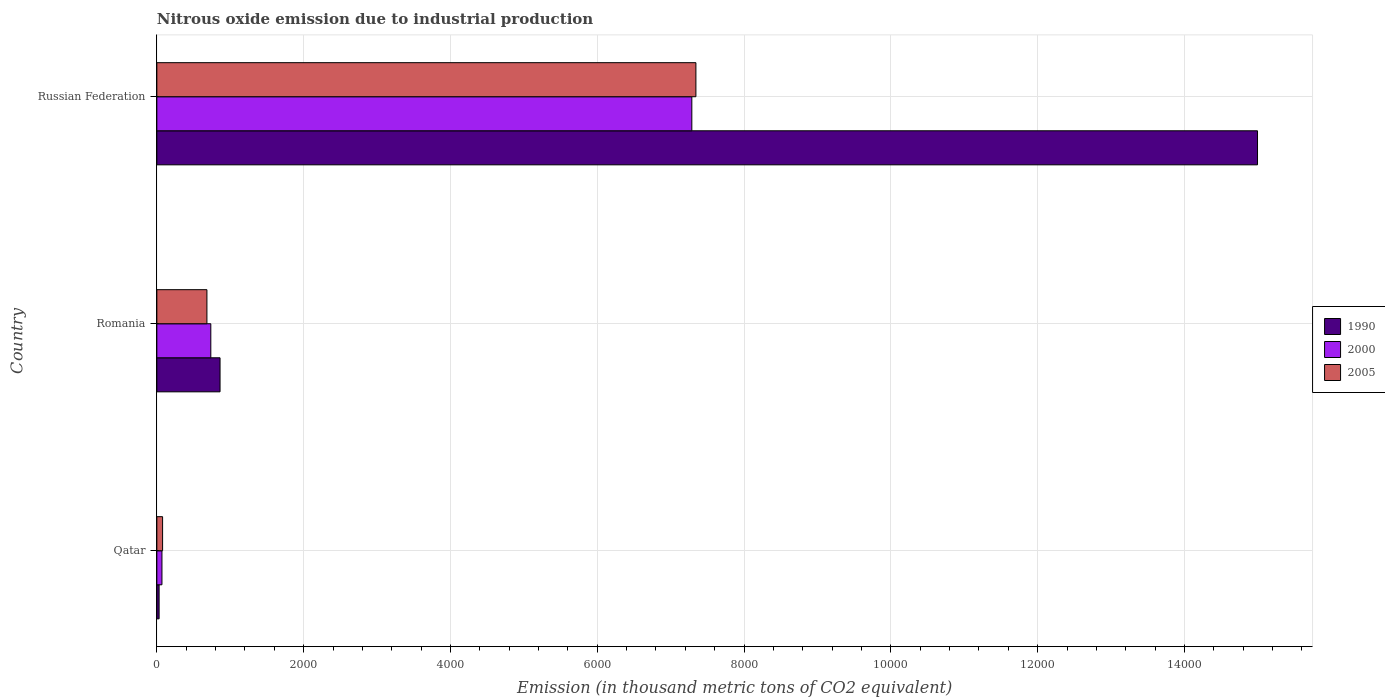Are the number of bars on each tick of the Y-axis equal?
Keep it short and to the point. Yes. What is the label of the 2nd group of bars from the top?
Make the answer very short. Romania. What is the amount of nitrous oxide emitted in 2005 in Qatar?
Make the answer very short. 78.2. Across all countries, what is the maximum amount of nitrous oxide emitted in 2005?
Your response must be concise. 7344.1. Across all countries, what is the minimum amount of nitrous oxide emitted in 2005?
Your answer should be compact. 78.2. In which country was the amount of nitrous oxide emitted in 2005 maximum?
Provide a short and direct response. Russian Federation. In which country was the amount of nitrous oxide emitted in 2005 minimum?
Provide a short and direct response. Qatar. What is the total amount of nitrous oxide emitted in 1990 in the graph?
Provide a short and direct response. 1.59e+04. What is the difference between the amount of nitrous oxide emitted in 2005 in Qatar and that in Russian Federation?
Make the answer very short. -7265.9. What is the difference between the amount of nitrous oxide emitted in 2005 in Russian Federation and the amount of nitrous oxide emitted in 2000 in Romania?
Offer a terse response. 6608.8. What is the average amount of nitrous oxide emitted in 2005 per country?
Offer a very short reply. 2701.53. What is the difference between the amount of nitrous oxide emitted in 1990 and amount of nitrous oxide emitted in 2005 in Romania?
Provide a succinct answer. 178.8. In how many countries, is the amount of nitrous oxide emitted in 2000 greater than 3200 thousand metric tons?
Your response must be concise. 1. What is the ratio of the amount of nitrous oxide emitted in 2005 in Qatar to that in Russian Federation?
Keep it short and to the point. 0.01. Is the amount of nitrous oxide emitted in 1990 in Qatar less than that in Romania?
Ensure brevity in your answer.  Yes. What is the difference between the highest and the second highest amount of nitrous oxide emitted in 2005?
Your answer should be compact. 6661.8. What is the difference between the highest and the lowest amount of nitrous oxide emitted in 1990?
Make the answer very short. 1.50e+04. In how many countries, is the amount of nitrous oxide emitted in 2005 greater than the average amount of nitrous oxide emitted in 2005 taken over all countries?
Ensure brevity in your answer.  1. Is the sum of the amount of nitrous oxide emitted in 2000 in Romania and Russian Federation greater than the maximum amount of nitrous oxide emitted in 1990 across all countries?
Provide a succinct answer. No. What does the 1st bar from the top in Qatar represents?
Ensure brevity in your answer.  2005. How many bars are there?
Offer a terse response. 9. Are all the bars in the graph horizontal?
Make the answer very short. Yes. How many countries are there in the graph?
Keep it short and to the point. 3. Are the values on the major ticks of X-axis written in scientific E-notation?
Make the answer very short. No. Does the graph contain any zero values?
Offer a very short reply. No. Where does the legend appear in the graph?
Provide a succinct answer. Center right. How are the legend labels stacked?
Your answer should be compact. Vertical. What is the title of the graph?
Your response must be concise. Nitrous oxide emission due to industrial production. What is the label or title of the X-axis?
Provide a short and direct response. Emission (in thousand metric tons of CO2 equivalent). What is the Emission (in thousand metric tons of CO2 equivalent) in 1990 in Qatar?
Keep it short and to the point. 30.8. What is the Emission (in thousand metric tons of CO2 equivalent) in 2000 in Qatar?
Keep it short and to the point. 69.5. What is the Emission (in thousand metric tons of CO2 equivalent) of 2005 in Qatar?
Your answer should be very brief. 78.2. What is the Emission (in thousand metric tons of CO2 equivalent) of 1990 in Romania?
Make the answer very short. 861.1. What is the Emission (in thousand metric tons of CO2 equivalent) in 2000 in Romania?
Your response must be concise. 735.3. What is the Emission (in thousand metric tons of CO2 equivalent) of 2005 in Romania?
Provide a short and direct response. 682.3. What is the Emission (in thousand metric tons of CO2 equivalent) in 1990 in Russian Federation?
Provide a short and direct response. 1.50e+04. What is the Emission (in thousand metric tons of CO2 equivalent) in 2000 in Russian Federation?
Ensure brevity in your answer.  7288.4. What is the Emission (in thousand metric tons of CO2 equivalent) in 2005 in Russian Federation?
Offer a terse response. 7344.1. Across all countries, what is the maximum Emission (in thousand metric tons of CO2 equivalent) of 1990?
Your response must be concise. 1.50e+04. Across all countries, what is the maximum Emission (in thousand metric tons of CO2 equivalent) of 2000?
Provide a short and direct response. 7288.4. Across all countries, what is the maximum Emission (in thousand metric tons of CO2 equivalent) in 2005?
Offer a very short reply. 7344.1. Across all countries, what is the minimum Emission (in thousand metric tons of CO2 equivalent) in 1990?
Your answer should be compact. 30.8. Across all countries, what is the minimum Emission (in thousand metric tons of CO2 equivalent) of 2000?
Give a very brief answer. 69.5. Across all countries, what is the minimum Emission (in thousand metric tons of CO2 equivalent) in 2005?
Offer a terse response. 78.2. What is the total Emission (in thousand metric tons of CO2 equivalent) of 1990 in the graph?
Provide a short and direct response. 1.59e+04. What is the total Emission (in thousand metric tons of CO2 equivalent) in 2000 in the graph?
Make the answer very short. 8093.2. What is the total Emission (in thousand metric tons of CO2 equivalent) in 2005 in the graph?
Offer a terse response. 8104.6. What is the difference between the Emission (in thousand metric tons of CO2 equivalent) of 1990 in Qatar and that in Romania?
Offer a very short reply. -830.3. What is the difference between the Emission (in thousand metric tons of CO2 equivalent) of 2000 in Qatar and that in Romania?
Your answer should be compact. -665.8. What is the difference between the Emission (in thousand metric tons of CO2 equivalent) in 2005 in Qatar and that in Romania?
Offer a terse response. -604.1. What is the difference between the Emission (in thousand metric tons of CO2 equivalent) in 1990 in Qatar and that in Russian Federation?
Ensure brevity in your answer.  -1.50e+04. What is the difference between the Emission (in thousand metric tons of CO2 equivalent) in 2000 in Qatar and that in Russian Federation?
Ensure brevity in your answer.  -7218.9. What is the difference between the Emission (in thousand metric tons of CO2 equivalent) of 2005 in Qatar and that in Russian Federation?
Your response must be concise. -7265.9. What is the difference between the Emission (in thousand metric tons of CO2 equivalent) in 1990 in Romania and that in Russian Federation?
Make the answer very short. -1.41e+04. What is the difference between the Emission (in thousand metric tons of CO2 equivalent) of 2000 in Romania and that in Russian Federation?
Provide a short and direct response. -6553.1. What is the difference between the Emission (in thousand metric tons of CO2 equivalent) in 2005 in Romania and that in Russian Federation?
Keep it short and to the point. -6661.8. What is the difference between the Emission (in thousand metric tons of CO2 equivalent) in 1990 in Qatar and the Emission (in thousand metric tons of CO2 equivalent) in 2000 in Romania?
Your answer should be compact. -704.5. What is the difference between the Emission (in thousand metric tons of CO2 equivalent) in 1990 in Qatar and the Emission (in thousand metric tons of CO2 equivalent) in 2005 in Romania?
Give a very brief answer. -651.5. What is the difference between the Emission (in thousand metric tons of CO2 equivalent) in 2000 in Qatar and the Emission (in thousand metric tons of CO2 equivalent) in 2005 in Romania?
Offer a very short reply. -612.8. What is the difference between the Emission (in thousand metric tons of CO2 equivalent) in 1990 in Qatar and the Emission (in thousand metric tons of CO2 equivalent) in 2000 in Russian Federation?
Offer a very short reply. -7257.6. What is the difference between the Emission (in thousand metric tons of CO2 equivalent) in 1990 in Qatar and the Emission (in thousand metric tons of CO2 equivalent) in 2005 in Russian Federation?
Give a very brief answer. -7313.3. What is the difference between the Emission (in thousand metric tons of CO2 equivalent) of 2000 in Qatar and the Emission (in thousand metric tons of CO2 equivalent) of 2005 in Russian Federation?
Offer a very short reply. -7274.6. What is the difference between the Emission (in thousand metric tons of CO2 equivalent) of 1990 in Romania and the Emission (in thousand metric tons of CO2 equivalent) of 2000 in Russian Federation?
Provide a short and direct response. -6427.3. What is the difference between the Emission (in thousand metric tons of CO2 equivalent) of 1990 in Romania and the Emission (in thousand metric tons of CO2 equivalent) of 2005 in Russian Federation?
Keep it short and to the point. -6483. What is the difference between the Emission (in thousand metric tons of CO2 equivalent) in 2000 in Romania and the Emission (in thousand metric tons of CO2 equivalent) in 2005 in Russian Federation?
Your answer should be compact. -6608.8. What is the average Emission (in thousand metric tons of CO2 equivalent) of 1990 per country?
Give a very brief answer. 5295.73. What is the average Emission (in thousand metric tons of CO2 equivalent) of 2000 per country?
Give a very brief answer. 2697.73. What is the average Emission (in thousand metric tons of CO2 equivalent) of 2005 per country?
Ensure brevity in your answer.  2701.53. What is the difference between the Emission (in thousand metric tons of CO2 equivalent) in 1990 and Emission (in thousand metric tons of CO2 equivalent) in 2000 in Qatar?
Give a very brief answer. -38.7. What is the difference between the Emission (in thousand metric tons of CO2 equivalent) of 1990 and Emission (in thousand metric tons of CO2 equivalent) of 2005 in Qatar?
Provide a succinct answer. -47.4. What is the difference between the Emission (in thousand metric tons of CO2 equivalent) in 2000 and Emission (in thousand metric tons of CO2 equivalent) in 2005 in Qatar?
Keep it short and to the point. -8.7. What is the difference between the Emission (in thousand metric tons of CO2 equivalent) in 1990 and Emission (in thousand metric tons of CO2 equivalent) in 2000 in Romania?
Your answer should be very brief. 125.8. What is the difference between the Emission (in thousand metric tons of CO2 equivalent) of 1990 and Emission (in thousand metric tons of CO2 equivalent) of 2005 in Romania?
Your answer should be compact. 178.8. What is the difference between the Emission (in thousand metric tons of CO2 equivalent) of 2000 and Emission (in thousand metric tons of CO2 equivalent) of 2005 in Romania?
Make the answer very short. 53. What is the difference between the Emission (in thousand metric tons of CO2 equivalent) of 1990 and Emission (in thousand metric tons of CO2 equivalent) of 2000 in Russian Federation?
Provide a short and direct response. 7706.9. What is the difference between the Emission (in thousand metric tons of CO2 equivalent) in 1990 and Emission (in thousand metric tons of CO2 equivalent) in 2005 in Russian Federation?
Give a very brief answer. 7651.2. What is the difference between the Emission (in thousand metric tons of CO2 equivalent) of 2000 and Emission (in thousand metric tons of CO2 equivalent) of 2005 in Russian Federation?
Your answer should be compact. -55.7. What is the ratio of the Emission (in thousand metric tons of CO2 equivalent) of 1990 in Qatar to that in Romania?
Keep it short and to the point. 0.04. What is the ratio of the Emission (in thousand metric tons of CO2 equivalent) of 2000 in Qatar to that in Romania?
Your answer should be compact. 0.09. What is the ratio of the Emission (in thousand metric tons of CO2 equivalent) in 2005 in Qatar to that in Romania?
Keep it short and to the point. 0.11. What is the ratio of the Emission (in thousand metric tons of CO2 equivalent) in 1990 in Qatar to that in Russian Federation?
Give a very brief answer. 0. What is the ratio of the Emission (in thousand metric tons of CO2 equivalent) in 2000 in Qatar to that in Russian Federation?
Your answer should be compact. 0.01. What is the ratio of the Emission (in thousand metric tons of CO2 equivalent) in 2005 in Qatar to that in Russian Federation?
Provide a short and direct response. 0.01. What is the ratio of the Emission (in thousand metric tons of CO2 equivalent) in 1990 in Romania to that in Russian Federation?
Your answer should be compact. 0.06. What is the ratio of the Emission (in thousand metric tons of CO2 equivalent) in 2000 in Romania to that in Russian Federation?
Your answer should be compact. 0.1. What is the ratio of the Emission (in thousand metric tons of CO2 equivalent) of 2005 in Romania to that in Russian Federation?
Your answer should be compact. 0.09. What is the difference between the highest and the second highest Emission (in thousand metric tons of CO2 equivalent) of 1990?
Your response must be concise. 1.41e+04. What is the difference between the highest and the second highest Emission (in thousand metric tons of CO2 equivalent) in 2000?
Offer a very short reply. 6553.1. What is the difference between the highest and the second highest Emission (in thousand metric tons of CO2 equivalent) of 2005?
Your answer should be compact. 6661.8. What is the difference between the highest and the lowest Emission (in thousand metric tons of CO2 equivalent) in 1990?
Keep it short and to the point. 1.50e+04. What is the difference between the highest and the lowest Emission (in thousand metric tons of CO2 equivalent) of 2000?
Your response must be concise. 7218.9. What is the difference between the highest and the lowest Emission (in thousand metric tons of CO2 equivalent) of 2005?
Make the answer very short. 7265.9. 